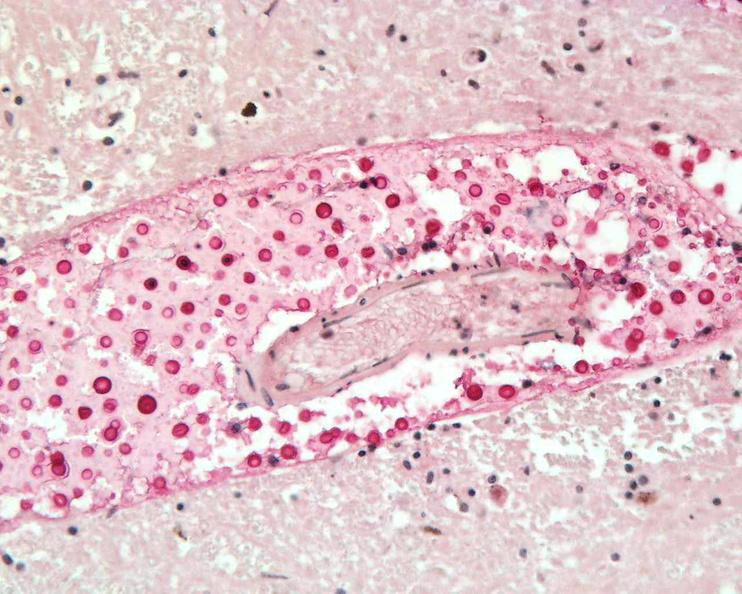what stain?
Answer the question using a single word or phrase. Mucicarmine 